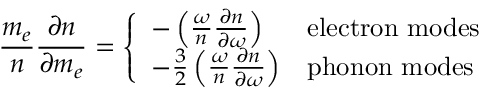<formula> <loc_0><loc_0><loc_500><loc_500>\frac { m _ { e } } { n } \frac { \partial n } { \partial m _ { e } } = \left \{ \begin{array} { l l } { - \left ( \frac { \omega } { n } \frac { \partial n } { \partial \omega } \right ) } & { e l e c t r o n m o d e s } \\ { - \frac { 3 } { 2 } \left ( \frac { \omega } { n } \frac { \partial n } { \partial \omega } \right ) } & { p h o n o n m o d e s } \end{array}</formula> 